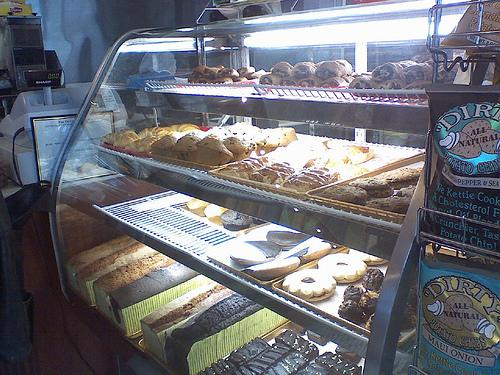Question: how many shelves?
Choices:
A. 1.
B. 3.
C. Four.
D. None.
Answer with the letter. Answer: C Question: where does it say Dirt?
Choices:
A. Name tag.
B. Potato chip bag.
C. Tote bag.
D. Candy package.
Answer with the letter. Answer: B Question: where are the muffins?
Choices:
A. Top shelf.
B. Second shelf.
C. Bottom shelf.
D. Counter.
Answer with the letter. Answer: B Question: what kind of store?
Choices:
A. Liquor store.
B. Grocer.
C. Bakery.
D. Pharmacy.
Answer with the letter. Answer: C Question: what color is the register?
Choices:
A. Gold.
B. White.
C. Tan.
D. Black.
Answer with the letter. Answer: B Question: where is the chocolate cake?
Choices:
A. Top shelf.
B. Second shelf.
C. Counter.
D. Bottom shelf.
Answer with the letter. Answer: D 